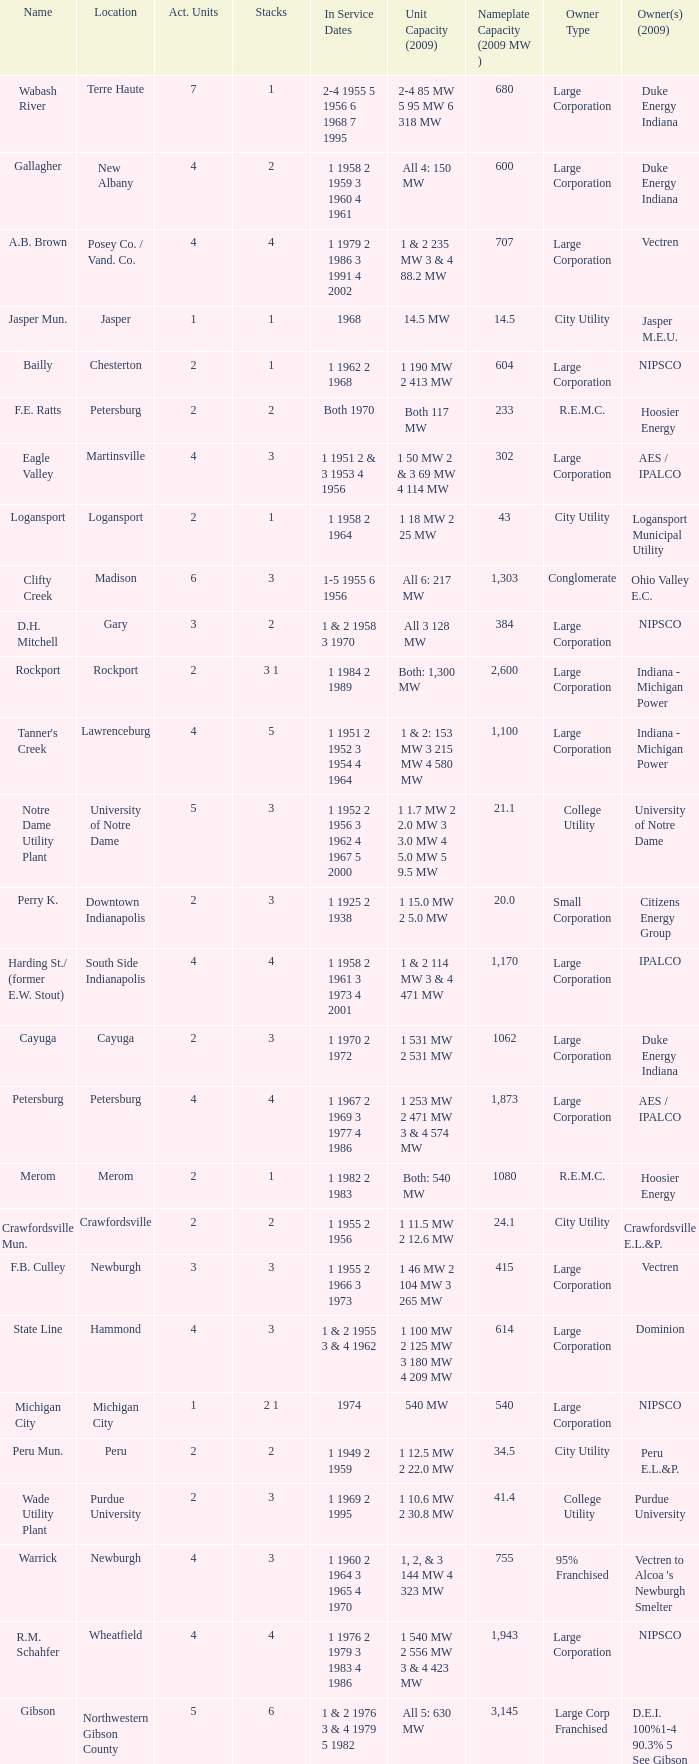Name the number of stacks for 1 & 2 235 mw 3 & 4 88.2 mw 1.0. 